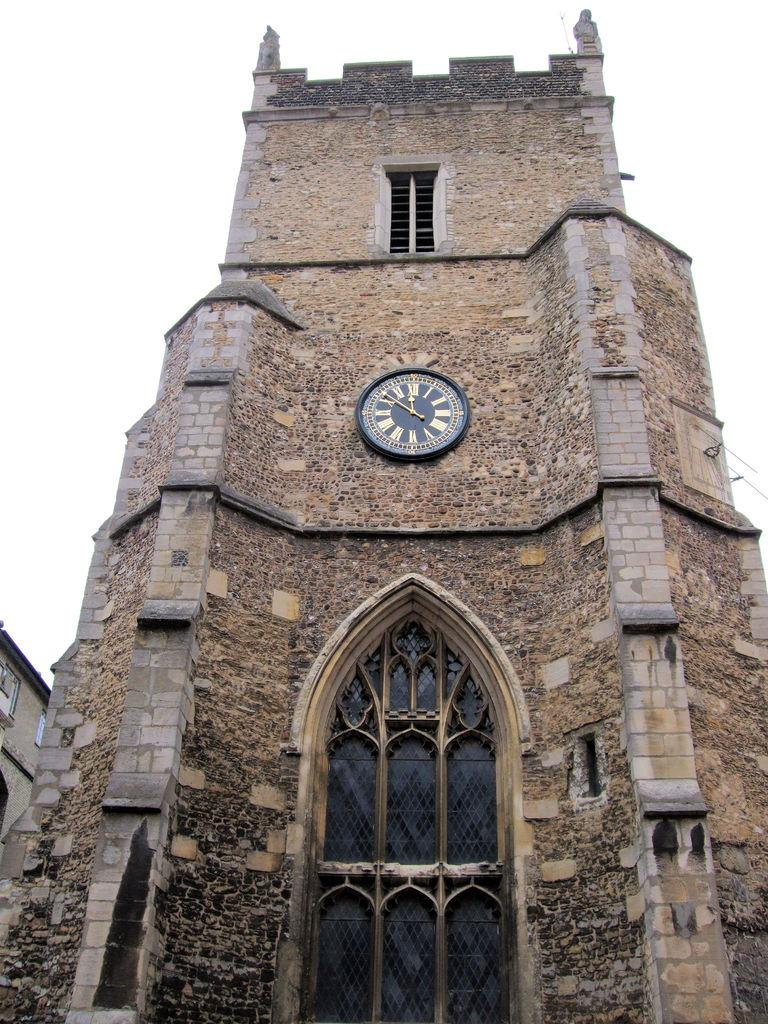<image>
Write a terse but informative summary of the picture. A tall brick building has a clock on it with the hour hand on the roman numeral "XII" 